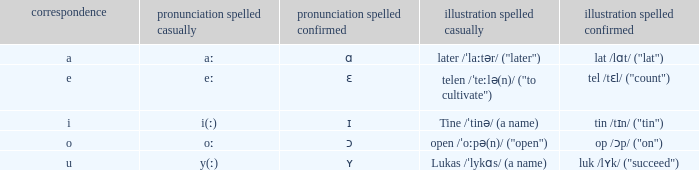What is Letter, when Example Spelled Checked is "tin /tɪn/ ("tin")"? I. 